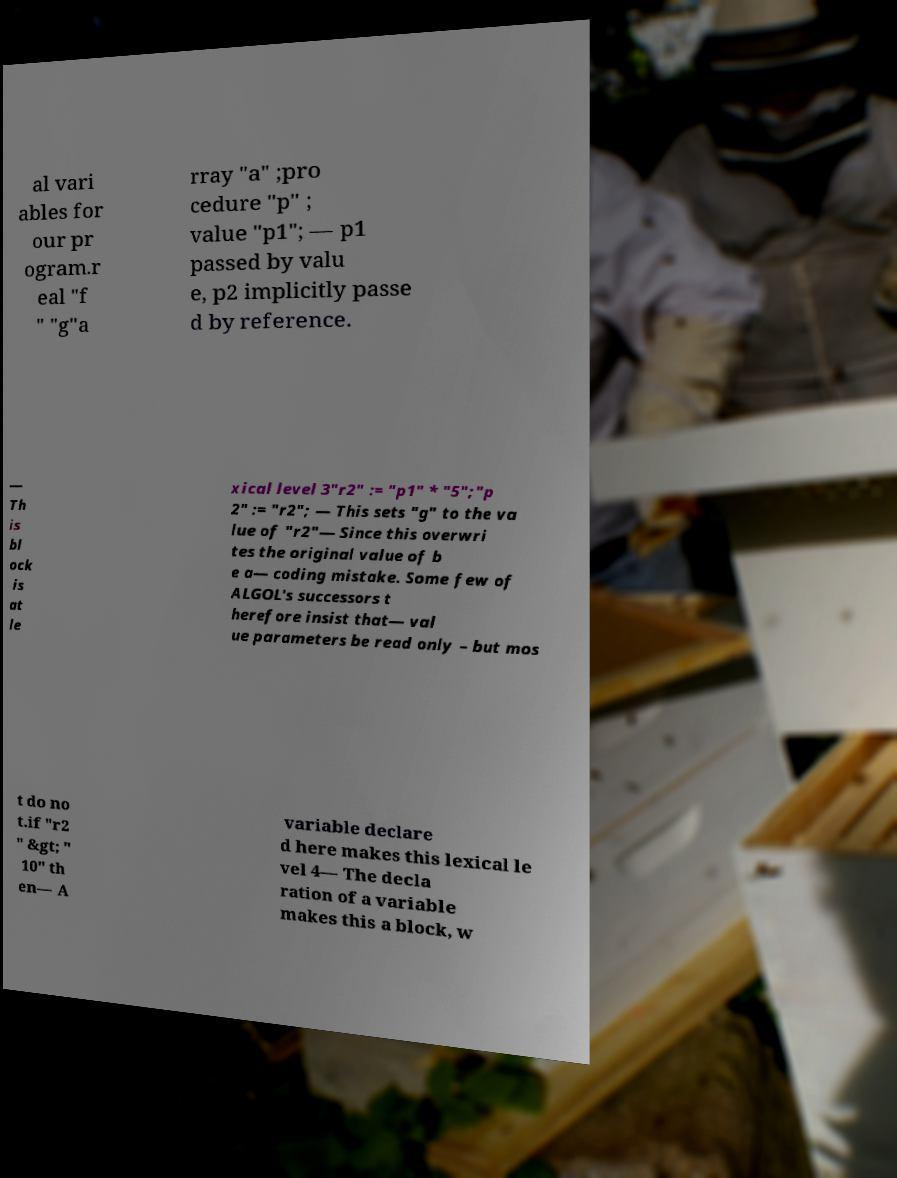Please read and relay the text visible in this image. What does it say? al vari ables for our pr ogram.r eal "f " "g"a rray "a" ;pro cedure "p" ; value "p1"; — p1 passed by valu e, p2 implicitly passe d by reference. — Th is bl ock is at le xical level 3"r2" := "p1" * "5";"p 2" := "r2"; — This sets "g" to the va lue of "r2"— Since this overwri tes the original value of b e a— coding mistake. Some few of ALGOL's successors t herefore insist that— val ue parameters be read only – but mos t do no t.if "r2 " &gt; " 10" th en— A variable declare d here makes this lexical le vel 4— The decla ration of a variable makes this a block, w 